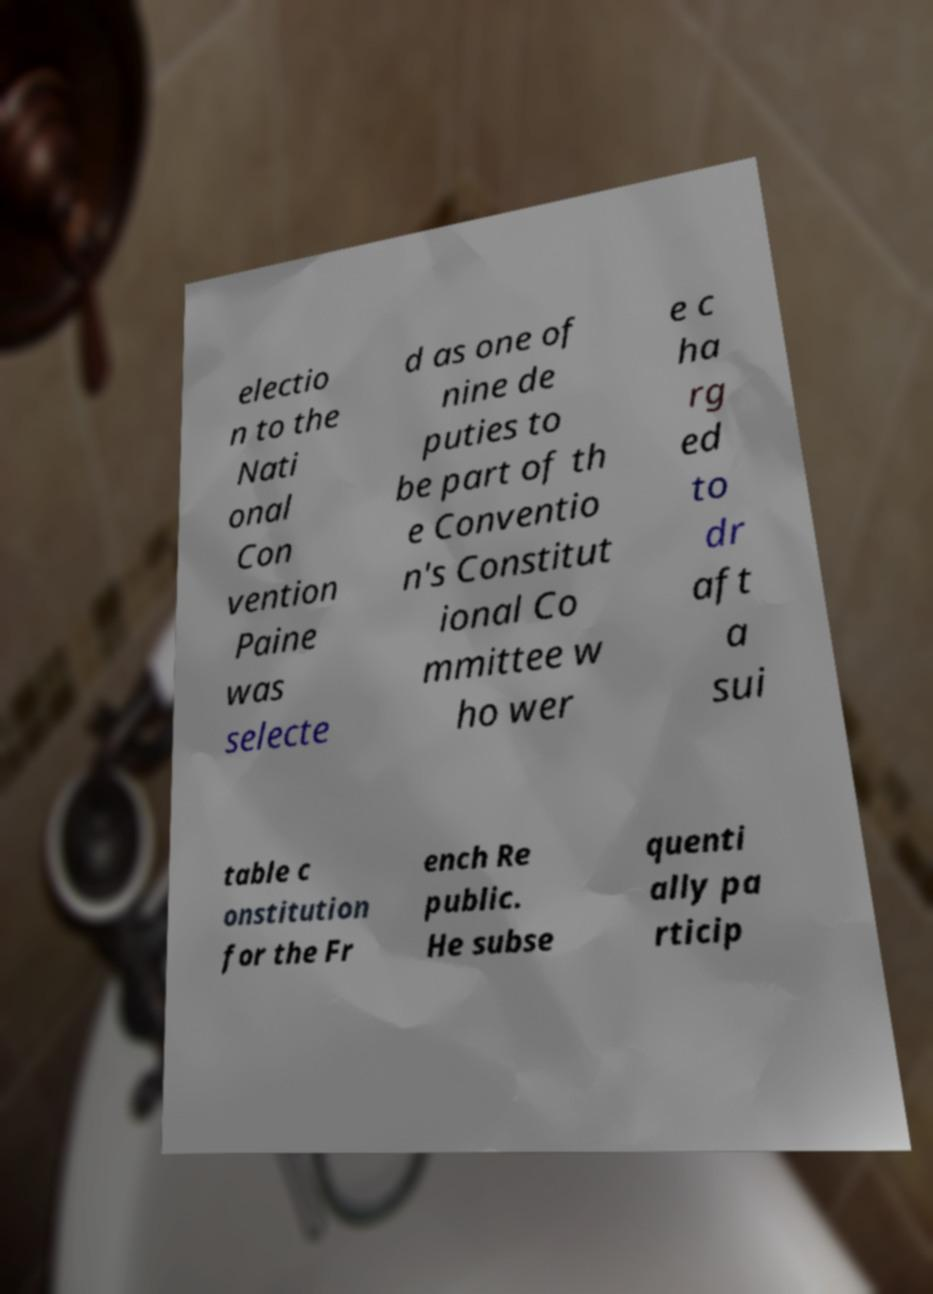Could you assist in decoding the text presented in this image and type it out clearly? electio n to the Nati onal Con vention Paine was selecte d as one of nine de puties to be part of th e Conventio n's Constitut ional Co mmittee w ho wer e c ha rg ed to dr aft a sui table c onstitution for the Fr ench Re public. He subse quenti ally pa rticip 